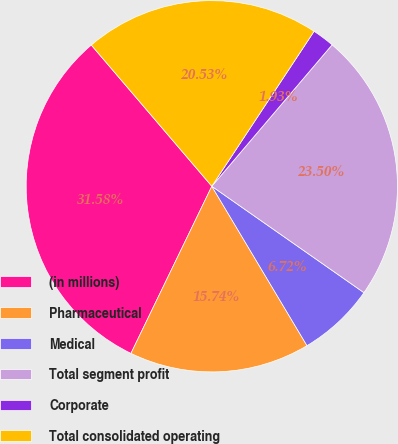Convert chart to OTSL. <chart><loc_0><loc_0><loc_500><loc_500><pie_chart><fcel>(in millions)<fcel>Pharmaceutical<fcel>Medical<fcel>Total segment profit<fcel>Corporate<fcel>Total consolidated operating<nl><fcel>31.58%<fcel>15.74%<fcel>6.72%<fcel>23.5%<fcel>1.93%<fcel>20.53%<nl></chart> 